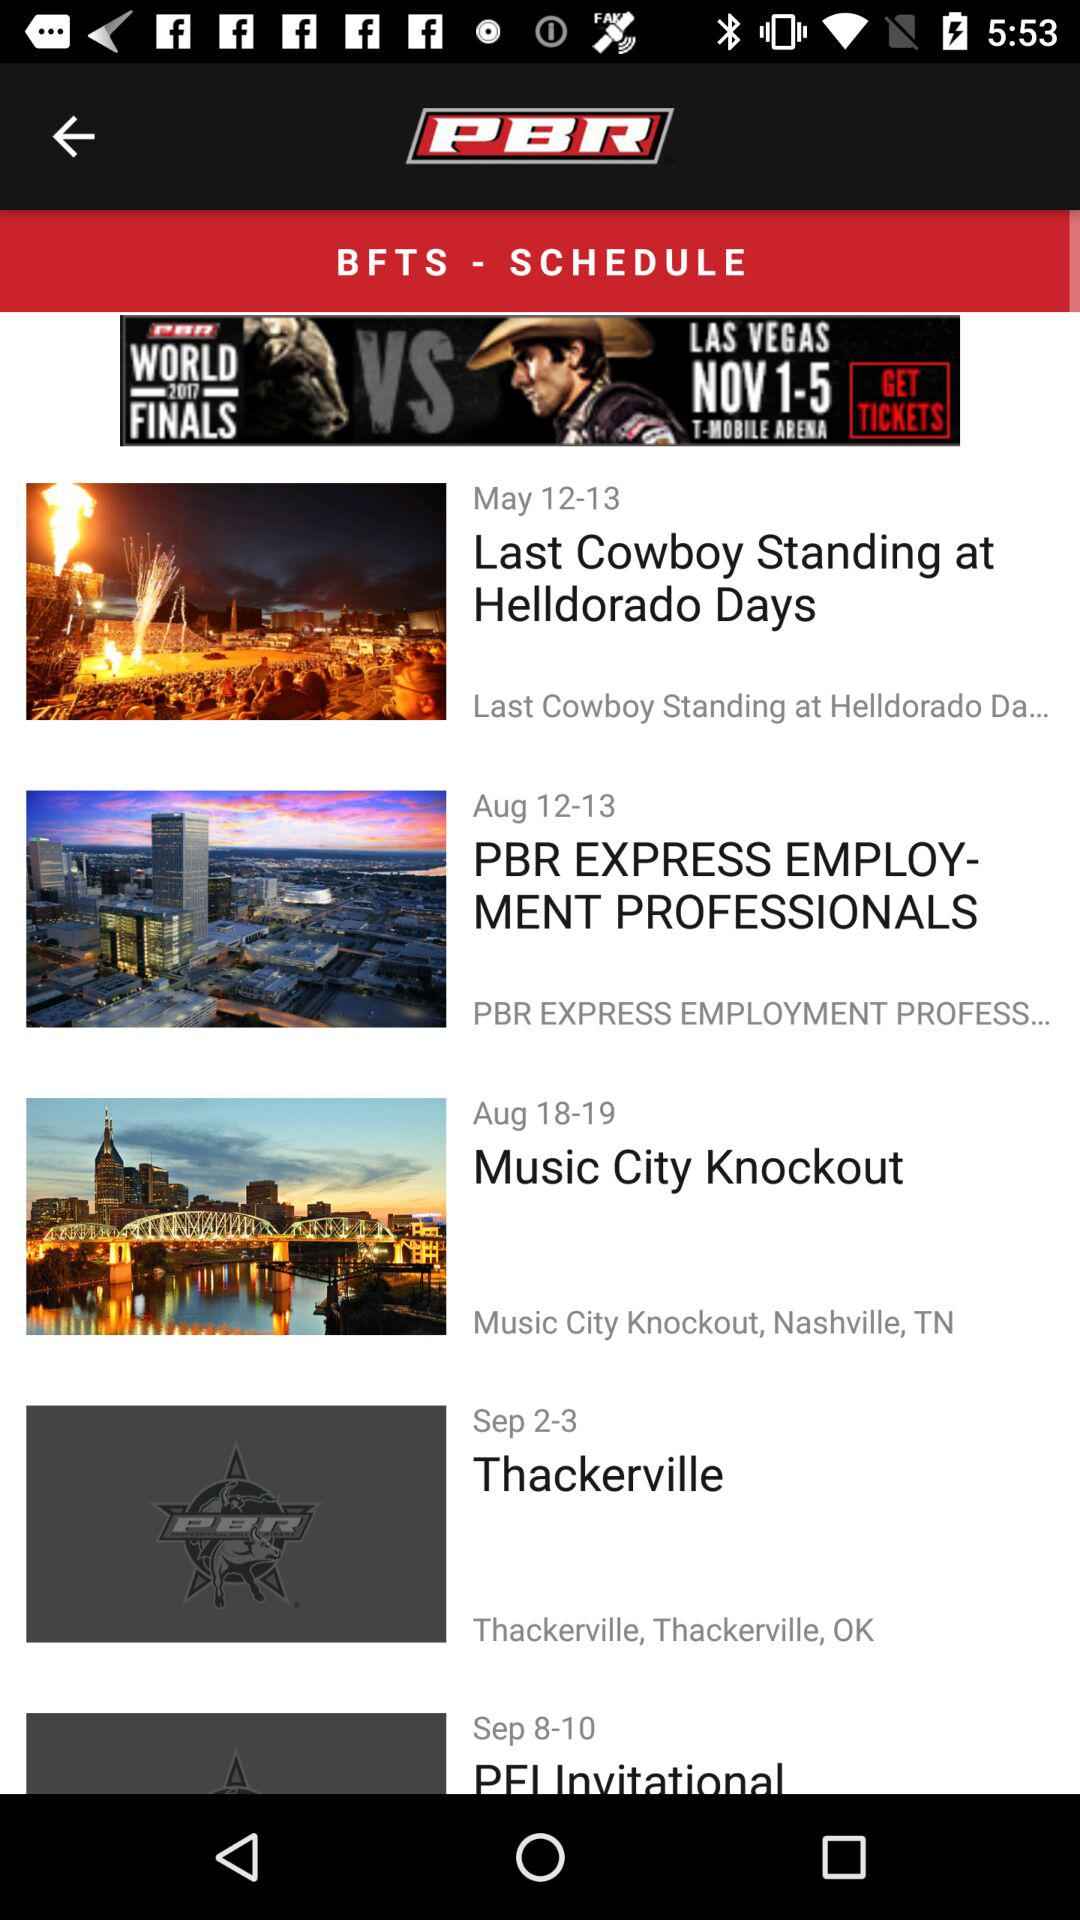What is the application name? The application name is "PBR". 